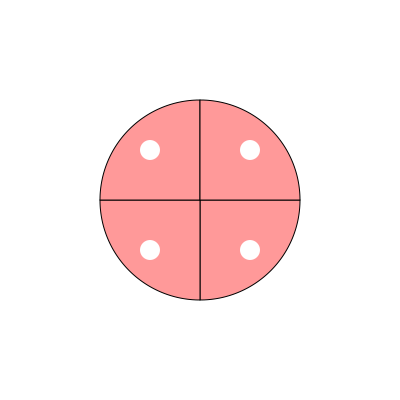In the fruit-inspired fabric pattern shown above, how many degrees of rotation are required to achieve full rotational symmetry? To determine the degrees of rotation required for full rotational symmetry, we need to follow these steps:

1. Observe the pattern: The design consists of four identical fruit slice shapes arranged around a central point.

2. Identify the order of rotational symmetry: The order of rotational symmetry is the number of times the pattern appears identical when rotated through a full 360°. In this case, we can see that the pattern repeats 4 times.

3. Calculate the angle of rotation:
   The angle of rotation is given by the formula:
   $$ \text{Angle of rotation} = \frac{360°}{\text{Order of rotational symmetry}} $$

   In this case:
   $$ \text{Angle of rotation} = \frac{360°}{4} = 90° $$

4. Verify: If we rotate the pattern by 90°, it will align perfectly with its original position, confirming our calculation.

Therefore, 90° of rotation is required to achieve full rotational symmetry in this fruit-inspired fabric pattern.
Answer: 90° 